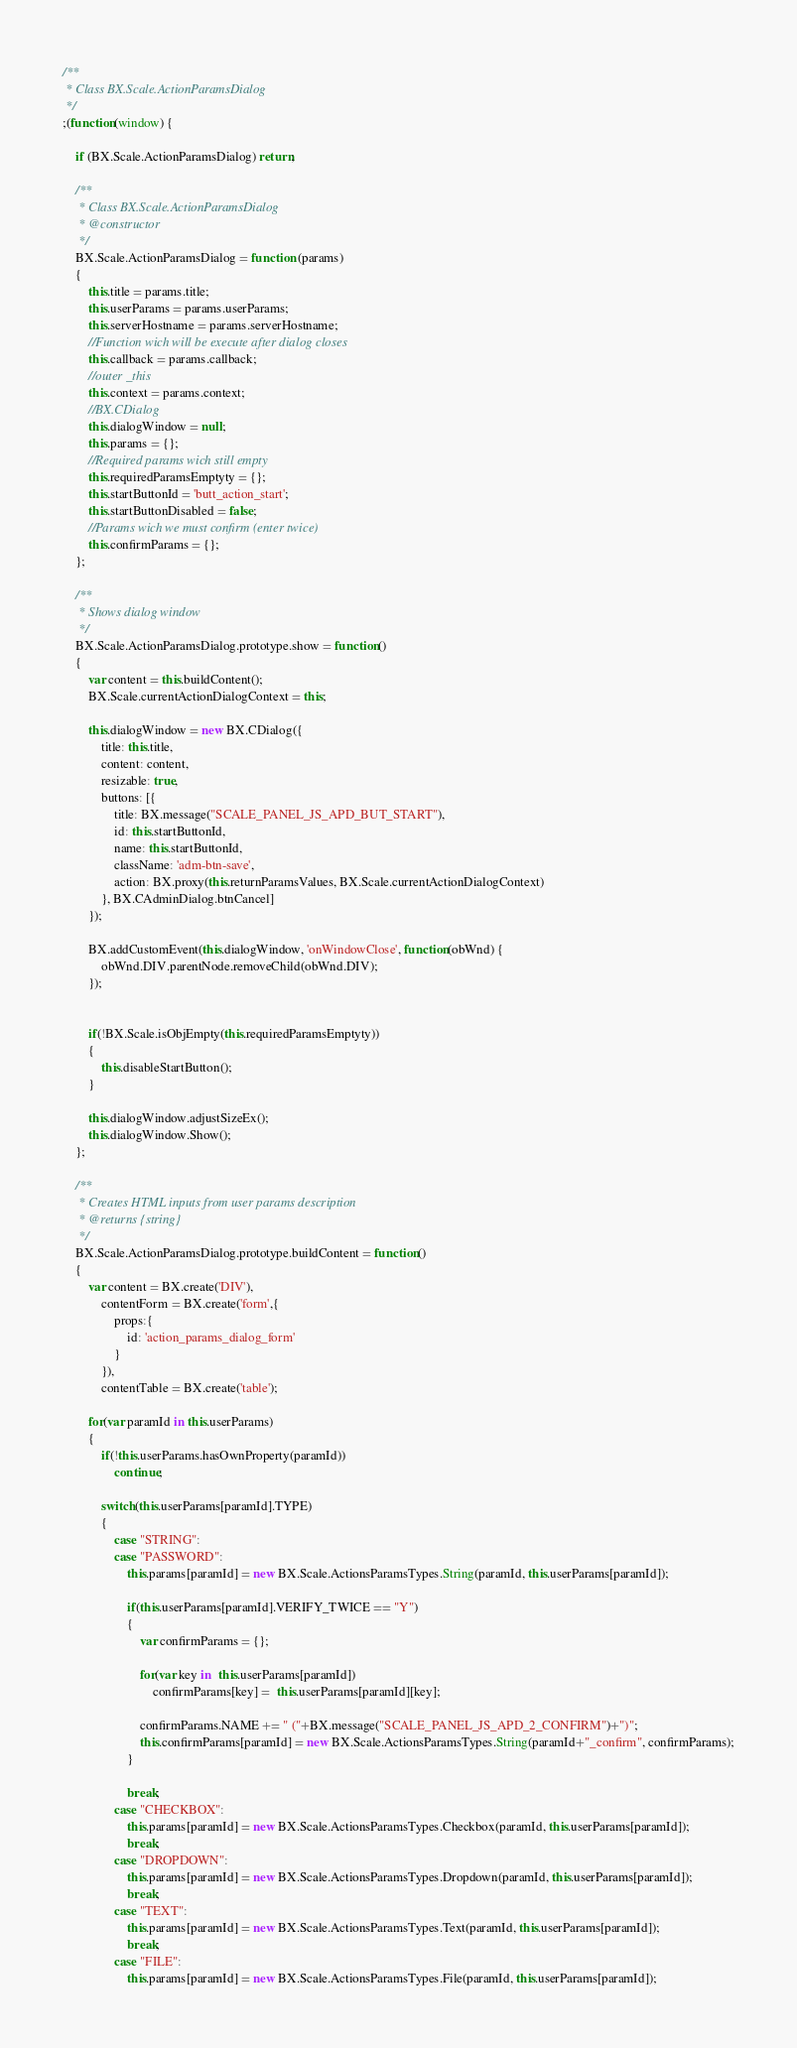Convert code to text. <code><loc_0><loc_0><loc_500><loc_500><_JavaScript_>/**
 * Class BX.Scale.ActionParamsDialog
 */
;(function(window) {

	if (BX.Scale.ActionParamsDialog) return;

	/**
	 * Class BX.Scale.ActionParamsDialog
	 * @constructor
	 */
	BX.Scale.ActionParamsDialog = function (params)
	{
		this.title = params.title;
		this.userParams = params.userParams;
		this.serverHostname = params.serverHostname;
		//Function wich will be execute after dialog closes
		this.callback = params.callback;
		//outer _this
		this.context = params.context;
		//BX.CDialog
		this.dialogWindow = null;
		this.params = {};
		//Required params wich still empty
		this.requiredParamsEmptyty = {};
		this.startButtonId = 'butt_action_start';
		this.startButtonDisabled = false;
		//Params wich we must confirm (enter twice)
		this.confirmParams = {};
	};

	/**
	 * Shows dialog window
	 */
	BX.Scale.ActionParamsDialog.prototype.show = function()
	{
		var content = this.buildContent();
		BX.Scale.currentActionDialogContext = this;

		this.dialogWindow = new BX.CDialog({
			title: this.title,
			content: content,
			resizable: true,
			buttons: [{
				title: BX.message("SCALE_PANEL_JS_APD_BUT_START"),
				id: this.startButtonId,
				name: this.startButtonId,
				className: 'adm-btn-save',
				action: BX.proxy(this.returnParamsValues, BX.Scale.currentActionDialogContext)
			}, BX.CAdminDialog.btnCancel]
		});

		BX.addCustomEvent(this.dialogWindow, 'onWindowClose', function(obWnd) {
			obWnd.DIV.parentNode.removeChild(obWnd.DIV);
		});


		if(!BX.Scale.isObjEmpty(this.requiredParamsEmptyty))
		{
			this.disableStartButton();
		}

		this.dialogWindow.adjustSizeEx();
		this.dialogWindow.Show();
	};

	/**
	 * Creates HTML inputs from user params description
	 * @returns {string}
	 */
	BX.Scale.ActionParamsDialog.prototype.buildContent = function()
	{
		var content = BX.create('DIV'),
			contentForm = BX.create('form',{
				props:{
					id: 'action_params_dialog_form'
				}
			}),
			contentTable = BX.create('table');

		for(var paramId in this.userParams)
		{
			if(!this.userParams.hasOwnProperty(paramId))
				continue;

			switch(this.userParams[paramId].TYPE)
			{
				case "STRING":
				case "PASSWORD":
					this.params[paramId] = new BX.Scale.ActionsParamsTypes.String(paramId, this.userParams[paramId]);

					if(this.userParams[paramId].VERIFY_TWICE == "Y")
					{
						var confirmParams = {};

						for(var key in  this.userParams[paramId])
							confirmParams[key] =  this.userParams[paramId][key];

						confirmParams.NAME += " ("+BX.message("SCALE_PANEL_JS_APD_2_CONFIRM")+")";
						this.confirmParams[paramId] = new BX.Scale.ActionsParamsTypes.String(paramId+"_confirm", confirmParams);
					}

					break;
				case "CHECKBOX":
					this.params[paramId] = new BX.Scale.ActionsParamsTypes.Checkbox(paramId, this.userParams[paramId]);
					break;
				case "DROPDOWN":
					this.params[paramId] = new BX.Scale.ActionsParamsTypes.Dropdown(paramId, this.userParams[paramId]);
					break;
				case "TEXT":
					this.params[paramId] = new BX.Scale.ActionsParamsTypes.Text(paramId, this.userParams[paramId]);
					break;
				case "FILE":
					this.params[paramId] = new BX.Scale.ActionsParamsTypes.File(paramId, this.userParams[paramId]);</code> 